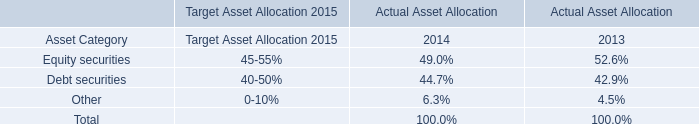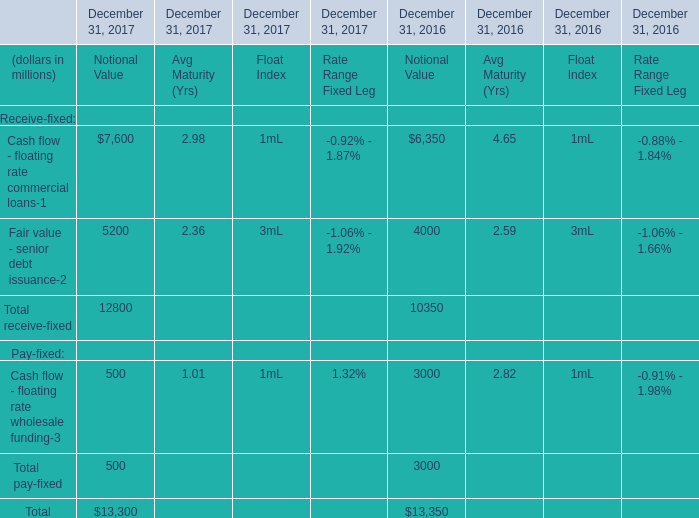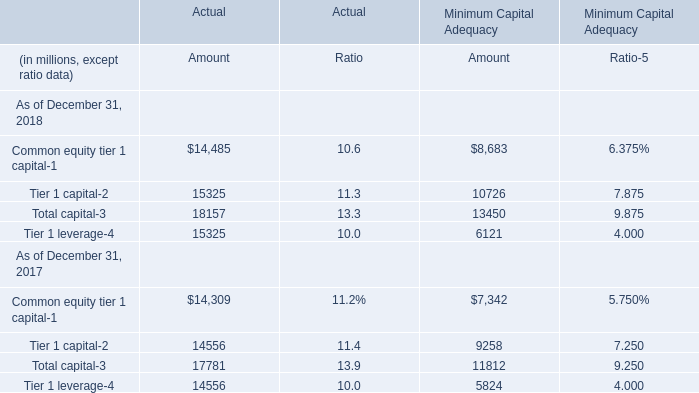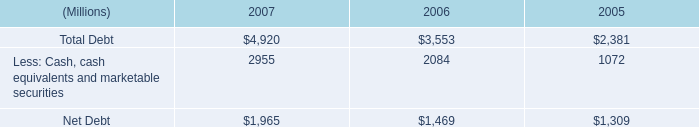What's the average of Net Debt of 2006, and Tier 1 leverage of Actual Amount ? 
Computations: ((1469.0 + 15325.0) / 2)
Answer: 8397.0. 